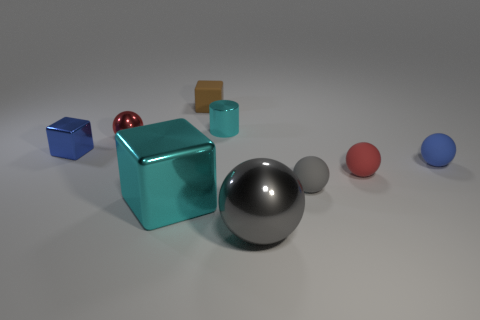There is a matte object behind the small blue object on the right side of the big cyan object; how many tiny brown matte cubes are on the right side of it?
Your answer should be very brief. 0. How many small things are yellow metallic blocks or spheres?
Keep it short and to the point. 4. Does the cyan object that is behind the red rubber thing have the same material as the small gray thing?
Provide a short and direct response. No. The red sphere in front of the object that is on the left side of the metal sphere behind the large cyan metal object is made of what material?
Your answer should be very brief. Rubber. Are there any other things that are the same size as the blue matte sphere?
Your response must be concise. Yes. How many metallic things are small blue balls or yellow things?
Offer a very short reply. 0. Are any gray things visible?
Your answer should be very brief. Yes. What color is the tiny metal block to the left of the tiny blue matte thing that is on the right side of the tiny cyan shiny cylinder?
Provide a short and direct response. Blue. What number of other objects are the same color as the cylinder?
Offer a very short reply. 1. What number of things are big gray metal balls or blue cubes that are in front of the brown thing?
Provide a succinct answer. 2. 